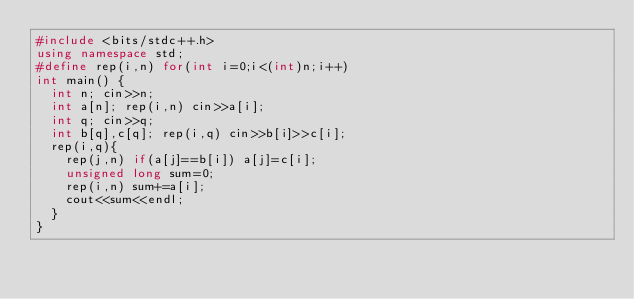<code> <loc_0><loc_0><loc_500><loc_500><_C++_>#include <bits/stdc++.h>
using namespace std;
#define rep(i,n) for(int i=0;i<(int)n;i++)
int main() {
  int n; cin>>n;
  int a[n]; rep(i,n) cin>>a[i];
  int q; cin>>q;
  int b[q],c[q]; rep(i,q) cin>>b[i]>>c[i];
  rep(i,q){
    rep(j,n) if(a[j]==b[i]) a[j]=c[i];
    unsigned long sum=0;
    rep(i,n) sum+=a[i];
    cout<<sum<<endl;
  }
}</code> 